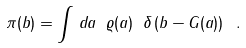<formula> <loc_0><loc_0><loc_500><loc_500>\pi ( b ) = \int \, d a \ \varrho ( a ) \ \delta \left ( b - G ( a ) \right ) \ .</formula> 